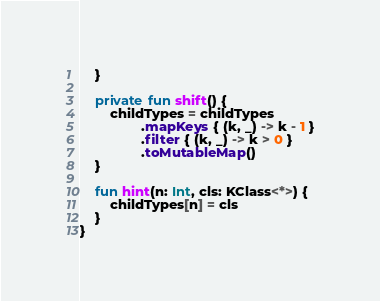<code> <loc_0><loc_0><loc_500><loc_500><_Kotlin_>    }

    private fun shift() {
        childTypes = childTypes
                .mapKeys { (k, _) -> k - 1 }
                .filter { (k, _) -> k > 0 }
                .toMutableMap()
    }

    fun hint(n: Int, cls: KClass<*>) {
        childTypes[n] = cls
    }
}</code> 